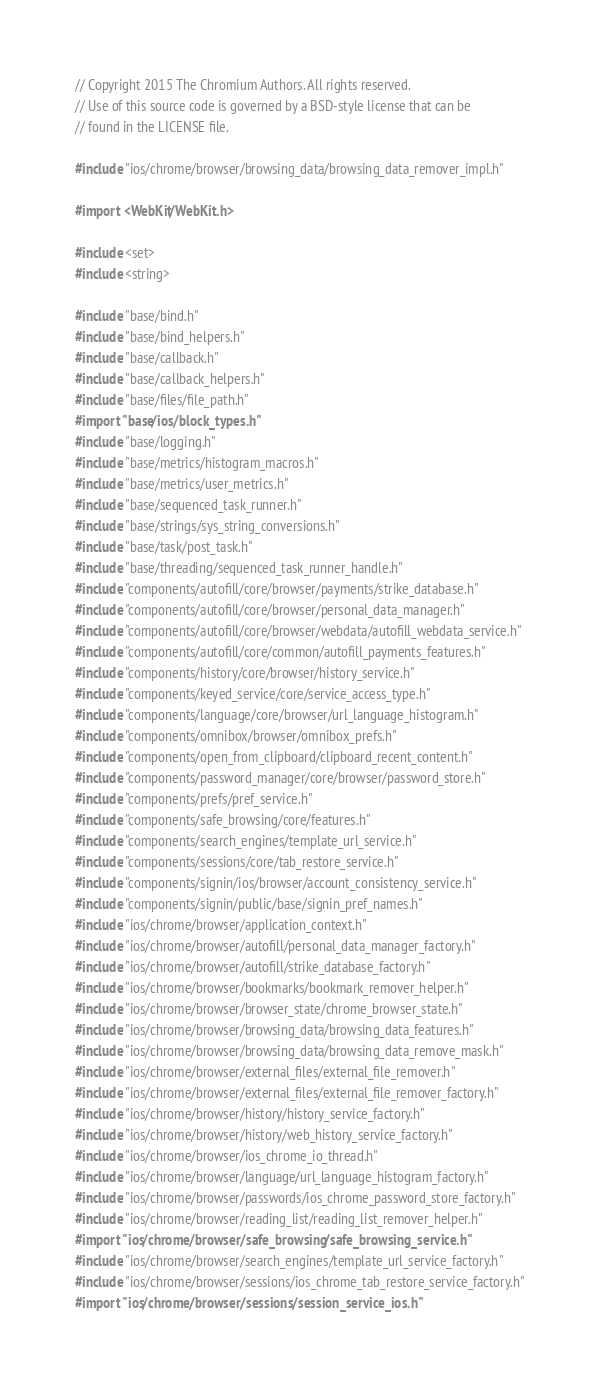<code> <loc_0><loc_0><loc_500><loc_500><_ObjectiveC_>// Copyright 2015 The Chromium Authors. All rights reserved.
// Use of this source code is governed by a BSD-style license that can be
// found in the LICENSE file.

#include "ios/chrome/browser/browsing_data/browsing_data_remover_impl.h"

#import <WebKit/WebKit.h>

#include <set>
#include <string>

#include "base/bind.h"
#include "base/bind_helpers.h"
#include "base/callback.h"
#include "base/callback_helpers.h"
#include "base/files/file_path.h"
#import "base/ios/block_types.h"
#include "base/logging.h"
#include "base/metrics/histogram_macros.h"
#include "base/metrics/user_metrics.h"
#include "base/sequenced_task_runner.h"
#include "base/strings/sys_string_conversions.h"
#include "base/task/post_task.h"
#include "base/threading/sequenced_task_runner_handle.h"
#include "components/autofill/core/browser/payments/strike_database.h"
#include "components/autofill/core/browser/personal_data_manager.h"
#include "components/autofill/core/browser/webdata/autofill_webdata_service.h"
#include "components/autofill/core/common/autofill_payments_features.h"
#include "components/history/core/browser/history_service.h"
#include "components/keyed_service/core/service_access_type.h"
#include "components/language/core/browser/url_language_histogram.h"
#include "components/omnibox/browser/omnibox_prefs.h"
#include "components/open_from_clipboard/clipboard_recent_content.h"
#include "components/password_manager/core/browser/password_store.h"
#include "components/prefs/pref_service.h"
#include "components/safe_browsing/core/features.h"
#include "components/search_engines/template_url_service.h"
#include "components/sessions/core/tab_restore_service.h"
#include "components/signin/ios/browser/account_consistency_service.h"
#include "components/signin/public/base/signin_pref_names.h"
#include "ios/chrome/browser/application_context.h"
#include "ios/chrome/browser/autofill/personal_data_manager_factory.h"
#include "ios/chrome/browser/autofill/strike_database_factory.h"
#include "ios/chrome/browser/bookmarks/bookmark_remover_helper.h"
#include "ios/chrome/browser/browser_state/chrome_browser_state.h"
#include "ios/chrome/browser/browsing_data/browsing_data_features.h"
#include "ios/chrome/browser/browsing_data/browsing_data_remove_mask.h"
#include "ios/chrome/browser/external_files/external_file_remover.h"
#include "ios/chrome/browser/external_files/external_file_remover_factory.h"
#include "ios/chrome/browser/history/history_service_factory.h"
#include "ios/chrome/browser/history/web_history_service_factory.h"
#include "ios/chrome/browser/ios_chrome_io_thread.h"
#include "ios/chrome/browser/language/url_language_histogram_factory.h"
#include "ios/chrome/browser/passwords/ios_chrome_password_store_factory.h"
#include "ios/chrome/browser/reading_list/reading_list_remover_helper.h"
#import "ios/chrome/browser/safe_browsing/safe_browsing_service.h"
#include "ios/chrome/browser/search_engines/template_url_service_factory.h"
#include "ios/chrome/browser/sessions/ios_chrome_tab_restore_service_factory.h"
#import "ios/chrome/browser/sessions/session_service_ios.h"</code> 